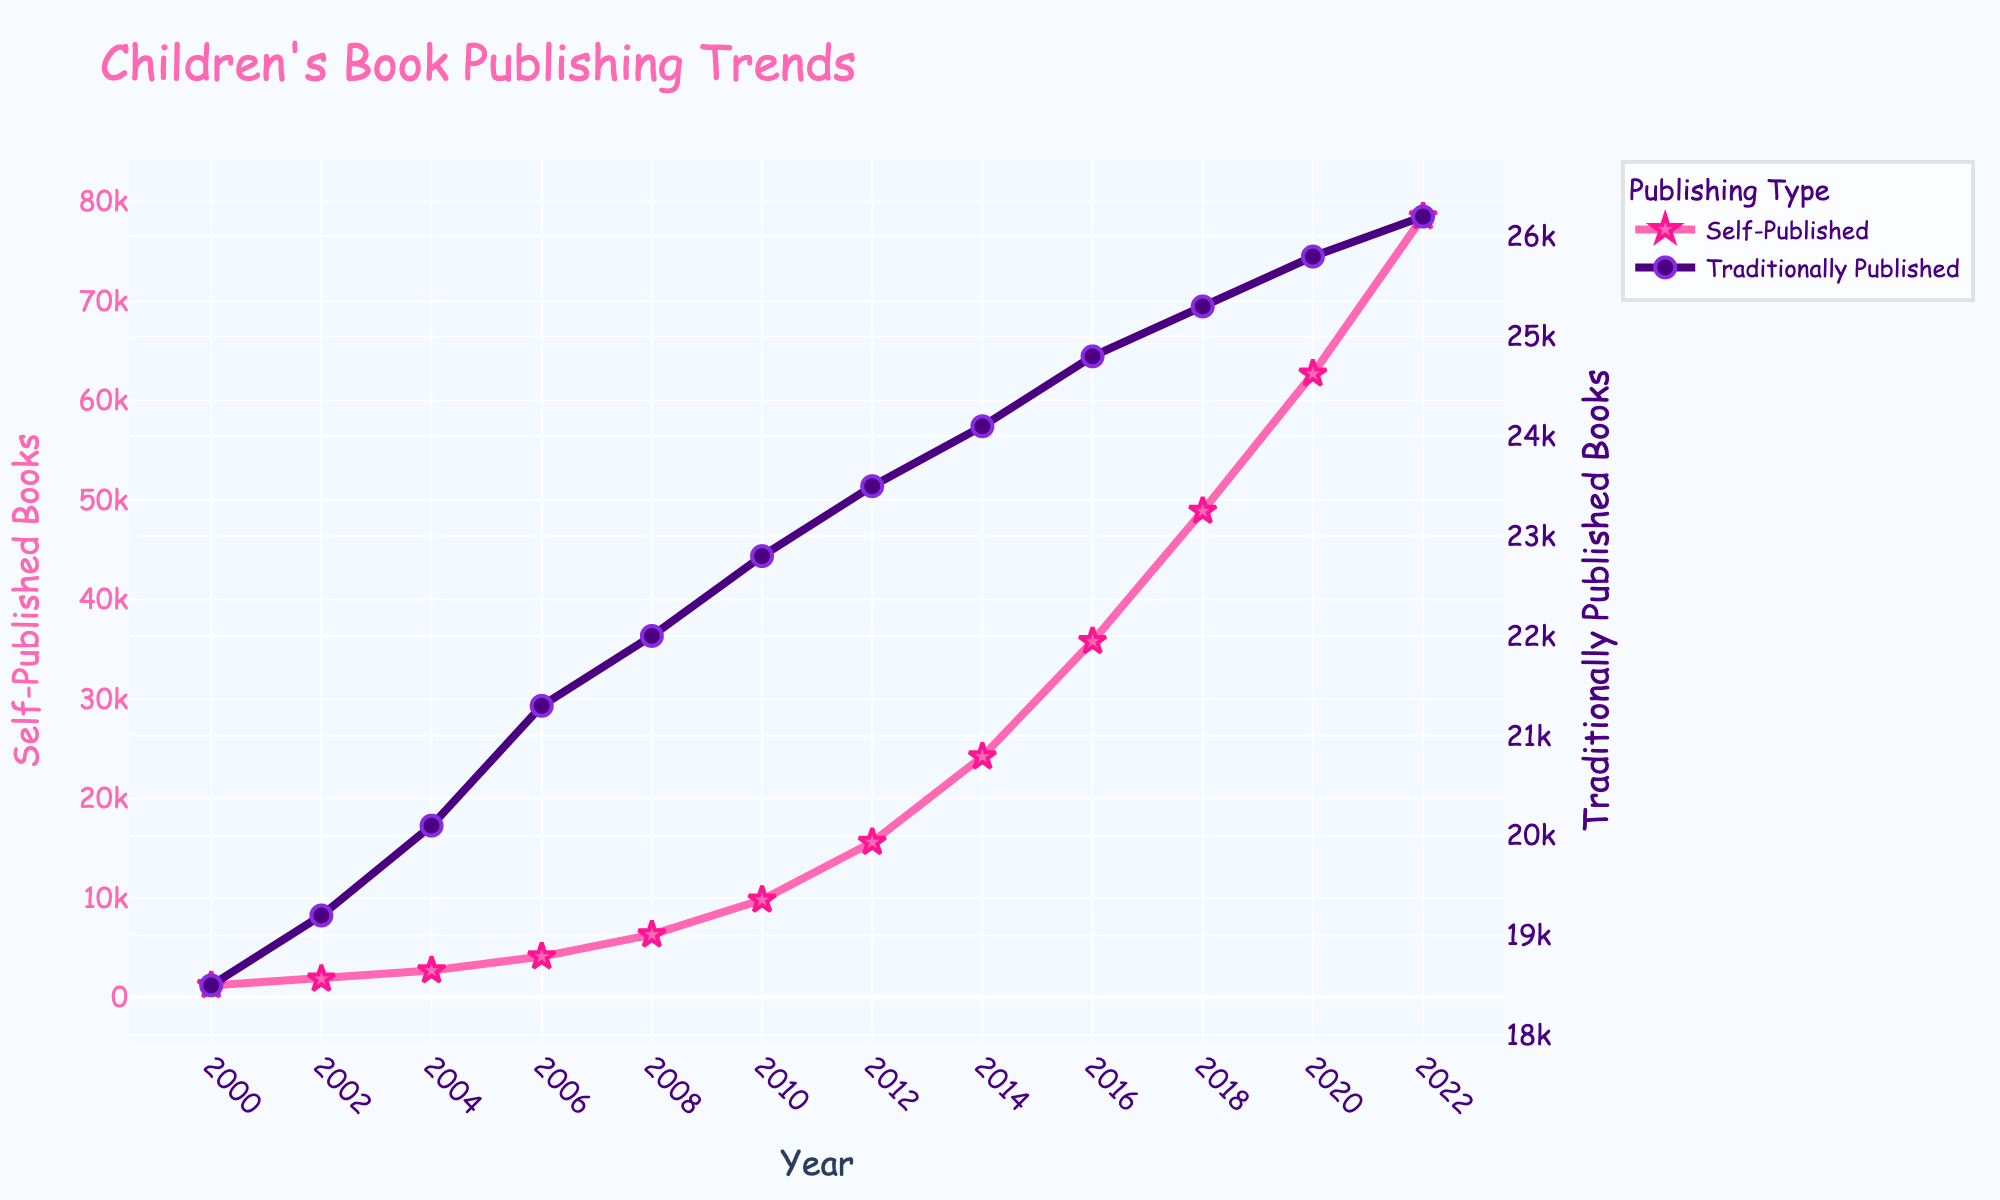What is the difference in the number of traditionally published children's books between 2000 and 2022? Look at the line for traditionally published books and note the values for 2000 and 2022. The number in 2000 is 18,500 and in 2022 it is 26,200. Subtract 18,500 from 26,200 to find the difference.
Answer: 7,700 Which year had the highest number of self-published children's books? Observe the pink line for self-published books. The peak occurs in 2022 with a value of 78,500.
Answer: 2022 How many more self-published books were there in 2022 compared to 2010? Identify the values for self-published books in 2022 and 2010. In 2022, it's 78,500 and in 2010 it’s 9,800. Subtract 9,800 from 78,500.
Answer: 68,700 How does the trend of self-published books compare to traditionally published books over the years? Assess the overall directions of both lines. The pink line for self-published books shows a steep upward trend, while the purple line for traditionally published books shows a gradual, smaller increase.
Answer: Steeper increase for self-published What is the average number of traditionally published children's books from 2000 to 2022? Note values for traditionally published books in all years, then sum them and divide by the number of years: (18500 + 19200 + 20100 + 21300 + 22000 + 22800 + 23500 + 24100 + 24800 + 25300 + 25800 + 26200) / 12.
Answer: 22,867 Between which consecutive years did self-published children's books see the highest increase? Calculate the difference between consecutive years for self-published books and find the maximum. The highest difference is between 2018 (48,900) and 2020 (62,700), which is 13,800.
Answer: 2018 and 2020 What is the ratio of self-published books to traditionally published books in 2022? Find the values for both in 2022: Self-published is 78,500, and traditionally published is 26,200. Divide 78,500 by 26,200.
Answer: Approx. 3:1 Which has a greater change in values from 2000 to 2022, self-published or traditionally published books? Calculate the change for both from 2000 to 2022. Self-published books went from 1,200 to 78,500 (a change of 77,300), while traditionally published books went from 18,500 to 26,200 (a change of 7,700).
Answer: Self-published What visual attributes help distinguish the two types of publications in the plot? Describe the visual markers used: The self-published books line is pink with star markers, while the traditionally published books line is purple with circle markers.
Answer: Pink stars vs. purple circles 